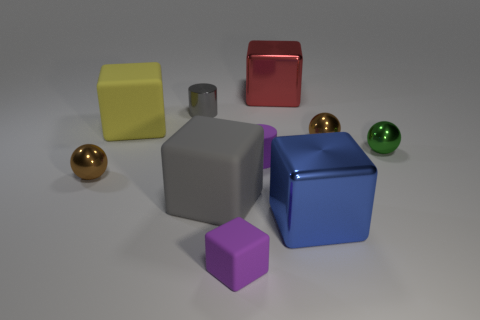Subtract all green balls. How many balls are left? 2 Subtract all yellow cylinders. How many brown spheres are left? 2 Subtract all balls. How many objects are left? 7 Subtract 2 cylinders. How many cylinders are left? 0 Subtract all gray cylinders. How many cylinders are left? 1 Subtract all gray cylinders. Subtract all gray cubes. How many cylinders are left? 1 Subtract all gray matte things. Subtract all blue metal things. How many objects are left? 8 Add 8 big gray blocks. How many big gray blocks are left? 9 Add 3 shiny things. How many shiny things exist? 9 Subtract 0 yellow balls. How many objects are left? 10 